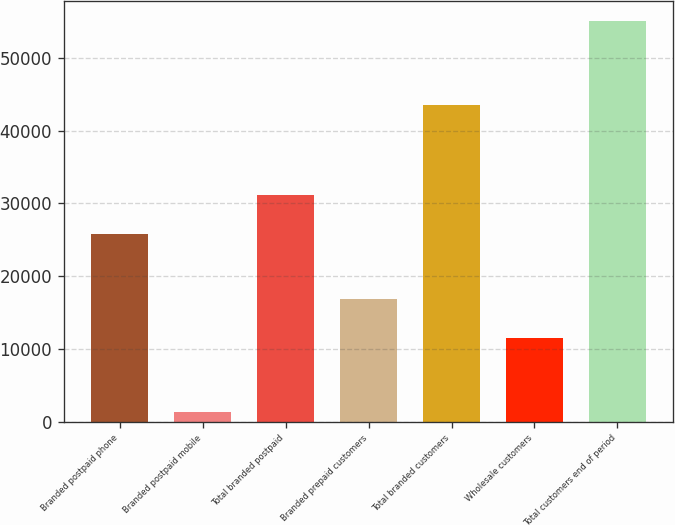<chart> <loc_0><loc_0><loc_500><loc_500><bar_chart><fcel>Branded postpaid phone<fcel>Branded postpaid mobile<fcel>Total branded postpaid<fcel>Branded prepaid customers<fcel>Total branded customers<fcel>Wholesale customers<fcel>Total customers end of period<nl><fcel>25844<fcel>1341<fcel>31211.7<fcel>16884.7<fcel>43501<fcel>11517<fcel>55018<nl></chart> 